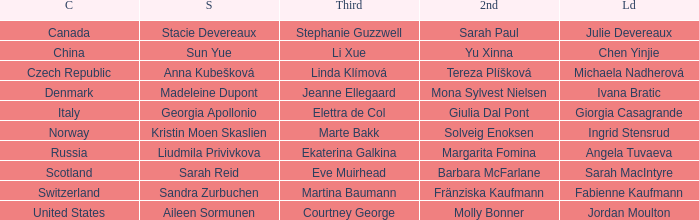What skip has denmark as the country? Madeleine Dupont. 